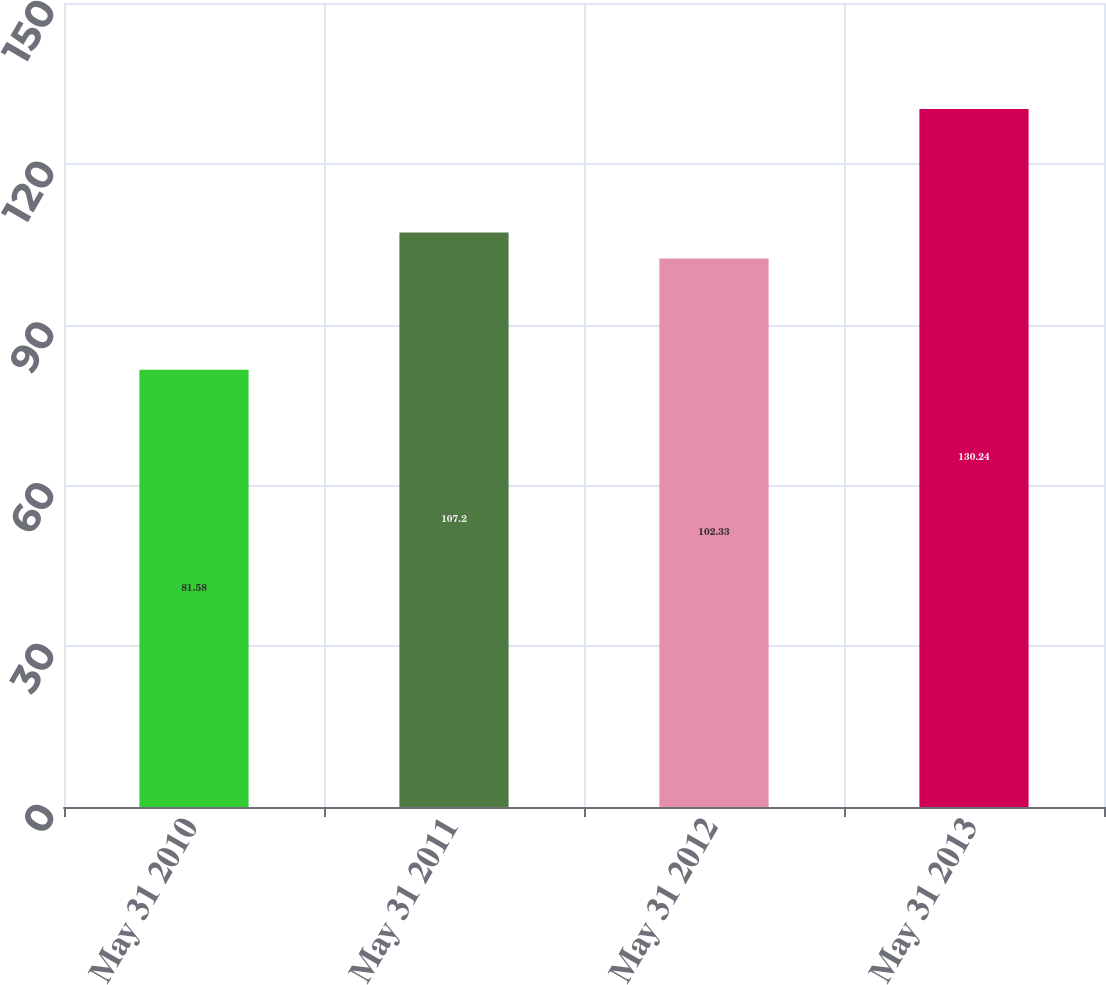Convert chart to OTSL. <chart><loc_0><loc_0><loc_500><loc_500><bar_chart><fcel>May 31 2010<fcel>May 31 2011<fcel>May 31 2012<fcel>May 31 2013<nl><fcel>81.58<fcel>107.2<fcel>102.33<fcel>130.24<nl></chart> 